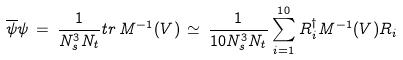<formula> <loc_0><loc_0><loc_500><loc_500>\overline { \psi } \psi \, = \, \frac { 1 } { N _ { s } ^ { 3 } N _ { t } } t r \, M ^ { - 1 } ( V ) \, \simeq \, \frac { 1 } { 1 0 N _ { s } ^ { 3 } N _ { t } } \sum ^ { 1 0 } _ { i = 1 } R _ { i } ^ { \dagger } M ^ { - 1 } ( V ) R _ { i } \,</formula> 